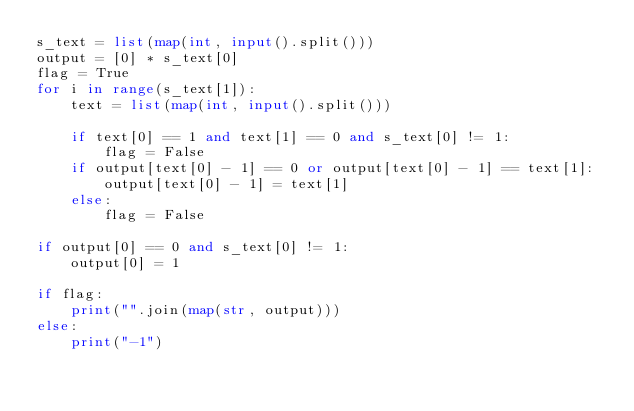Convert code to text. <code><loc_0><loc_0><loc_500><loc_500><_Python_>s_text = list(map(int, input().split()))
output = [0] * s_text[0]
flag = True
for i in range(s_text[1]):
    text = list(map(int, input().split()))

    if text[0] == 1 and text[1] == 0 and s_text[0] != 1:
        flag = False
    if output[text[0] - 1] == 0 or output[text[0] - 1] == text[1]:
        output[text[0] - 1] = text[1]
    else:
        flag = False

if output[0] == 0 and s_text[0] != 1:
    output[0] = 1

if flag:
    print("".join(map(str, output)))
else:
    print("-1")</code> 